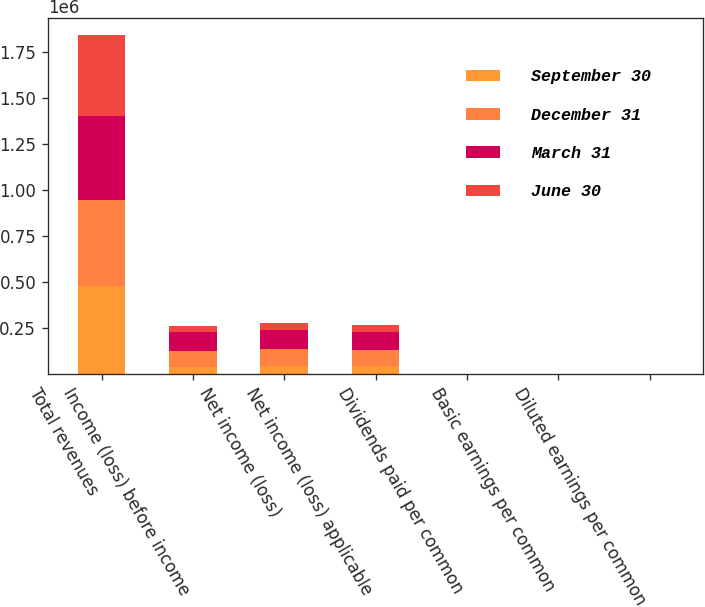Convert chart. <chart><loc_0><loc_0><loc_500><loc_500><stacked_bar_chart><ecel><fcel>Total revenues<fcel>Income (loss) before income<fcel>Net income (loss)<fcel>Net income (loss) applicable<fcel>Dividends paid per common<fcel>Basic earnings per common<fcel>Diluted earnings per common<nl><fcel>September 30<fcel>479197<fcel>37331<fcel>43237<fcel>40232<fcel>0.37<fcel>0.08<fcel>0.08<nl><fcel>December 31<fcel>469551<fcel>88375<fcel>92928<fcel>89942<fcel>0.37<fcel>0.19<fcel>0.19<nl><fcel>March 31<fcel>456022<fcel>98908<fcel>102926<fcel>99371<fcel>0.37<fcel>0.21<fcel>0.21<nl><fcel>June 30<fcel>441919<fcel>37331<fcel>37331<fcel>37331<fcel>0.37<fcel>1.75<fcel>1.73<nl></chart> 